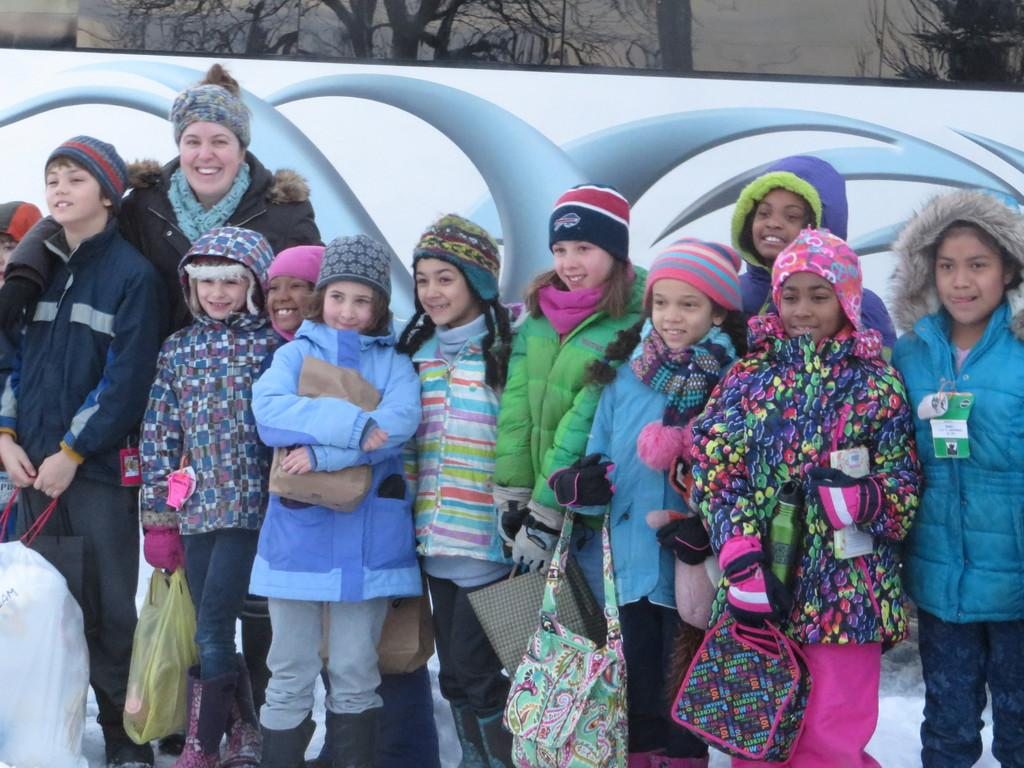What is the main subject of the image? The main subject of the image is a group of girls. What are the girls doing in the image? The girls are standing in the image. What expressions do the girls have in the image? The girls are smiling in the image. What clothing items are the girls wearing in the image? The girls are wearing coats and caps in the image. What type of bun is the girl in the middle holding in the image? There is no bun visible in the image; the girls are wearing caps, not holding buns. 